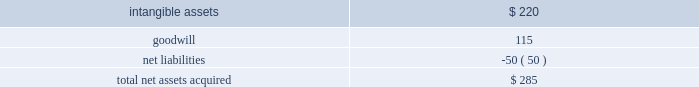News corporation notes to the consolidated financial statements consideration over the fair value of the net tangible and intangible assets acquired was recorded as goodwill .
The allocation is as follows ( in millions ) : assets acquired: .
The acquired intangible assets primarily relate to broadcast licenses , which have a fair value of approximately $ 185 million , tradenames , which have a fair value of approximately $ 27 million , and customer relationships with a fair value of approximately $ 8 million .
The broadcast licenses and tradenames have indefinite lives and the customer relationships are being amortized over a weighted-average useful life of approximately 6 years .
Wireless group 2019s results are included within the news and information services segment , and it is considered a separate reporting unit for purposes of the company 2019s annual goodwill impairment review .
Rea group european business in december 2016 , rea group , in which the company holds a 61.6% ( 61.6 % ) interest , sold its european business for approximately $ 140 million ( approximately 20ac133 million ) in cash , which resulted in a pre-tax gain of $ 107 million for the fiscal year ended june 30 , 2017 .
The sale allows rea group to focus on its core businesses in australia and asia .
In addition to the acquisitions noted above and the investments referenced in note 6 2014investments , the company used $ 62 million of cash for additional acquisitions during fiscal 2017 , primarily consisting of australian regional media ( 201carm 201d ) .
Arm 2019s results are included within the news and information services segment .
Note 5 .
Restructuring programs the company recorded restructuring charges of $ 92 million , $ 71 million and $ 142 million for the fiscal years ended june 30 , 2019 , 2018 and 2017 , respectively , of which $ 77 million , $ 58 million and $ 133 million related to the news and information services segment , respectively .
The restructuring charges recorded in fiscal 2019 , 2018 and 2017 were primarily for employee termination benefits. .
What percent of total net assets acquired was intangible assets? 
Computations: (220 / 285)
Answer: 0.77193. 